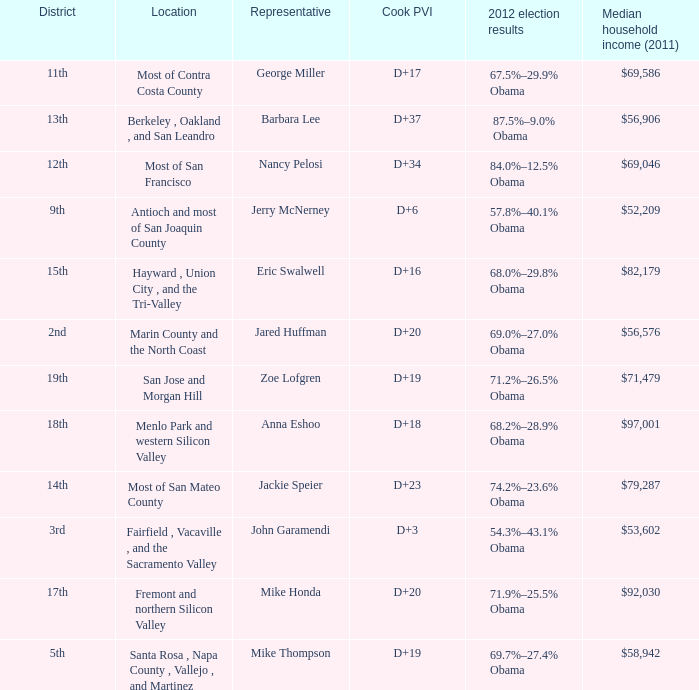What is the Cook PVI for the location that has a representative of Mike Thompson? D+19. 